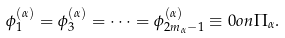Convert formula to latex. <formula><loc_0><loc_0><loc_500><loc_500>\phi ^ { ( \alpha ) } _ { 1 } = \phi ^ { ( \alpha ) } _ { 3 } = \dots = \phi ^ { ( \alpha ) } _ { 2 m _ { \alpha } - 1 } \equiv 0 o n \Pi _ { \alpha } .</formula> 